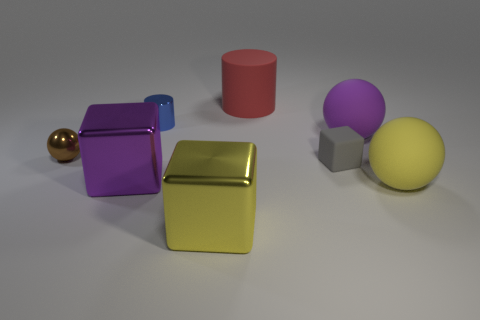Add 1 yellow metallic blocks. How many objects exist? 9 Subtract all balls. How many objects are left? 5 Add 8 large purple metal objects. How many large purple metal objects are left? 9 Add 2 metal cylinders. How many metal cylinders exist? 3 Subtract 0 yellow cylinders. How many objects are left? 8 Subtract all small yellow cylinders. Subtract all tiny gray things. How many objects are left? 7 